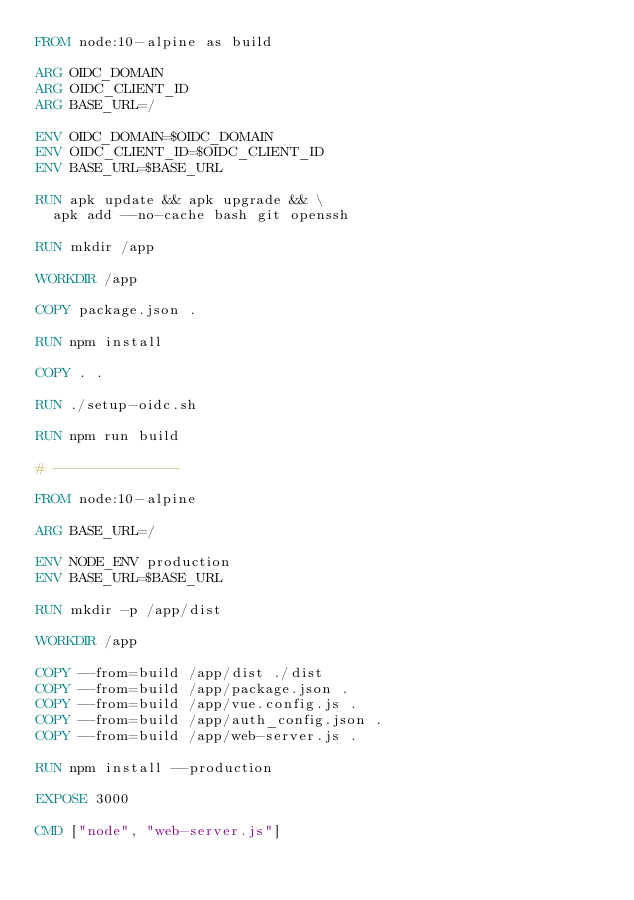Convert code to text. <code><loc_0><loc_0><loc_500><loc_500><_Dockerfile_>FROM node:10-alpine as build

ARG OIDC_DOMAIN
ARG OIDC_CLIENT_ID
ARG BASE_URL=/

ENV OIDC_DOMAIN=$OIDC_DOMAIN
ENV OIDC_CLIENT_ID=$OIDC_CLIENT_ID
ENV BASE_URL=$BASE_URL

RUN apk update && apk upgrade && \
  apk add --no-cache bash git openssh

RUN mkdir /app

WORKDIR /app

COPY package.json .

RUN npm install

COPY . .

RUN ./setup-oidc.sh

RUN npm run build

# ---------------

FROM node:10-alpine

ARG BASE_URL=/

ENV NODE_ENV production
ENV BASE_URL=$BASE_URL

RUN mkdir -p /app/dist

WORKDIR /app

COPY --from=build /app/dist ./dist
COPY --from=build /app/package.json .
COPY --from=build /app/vue.config.js .
COPY --from=build /app/auth_config.json .
COPY --from=build /app/web-server.js .

RUN npm install --production

EXPOSE 3000

CMD ["node", "web-server.js"]
</code> 